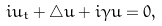<formula> <loc_0><loc_0><loc_500><loc_500>i u _ { t } + \bigtriangleup u + i \gamma u = 0 ,</formula> 